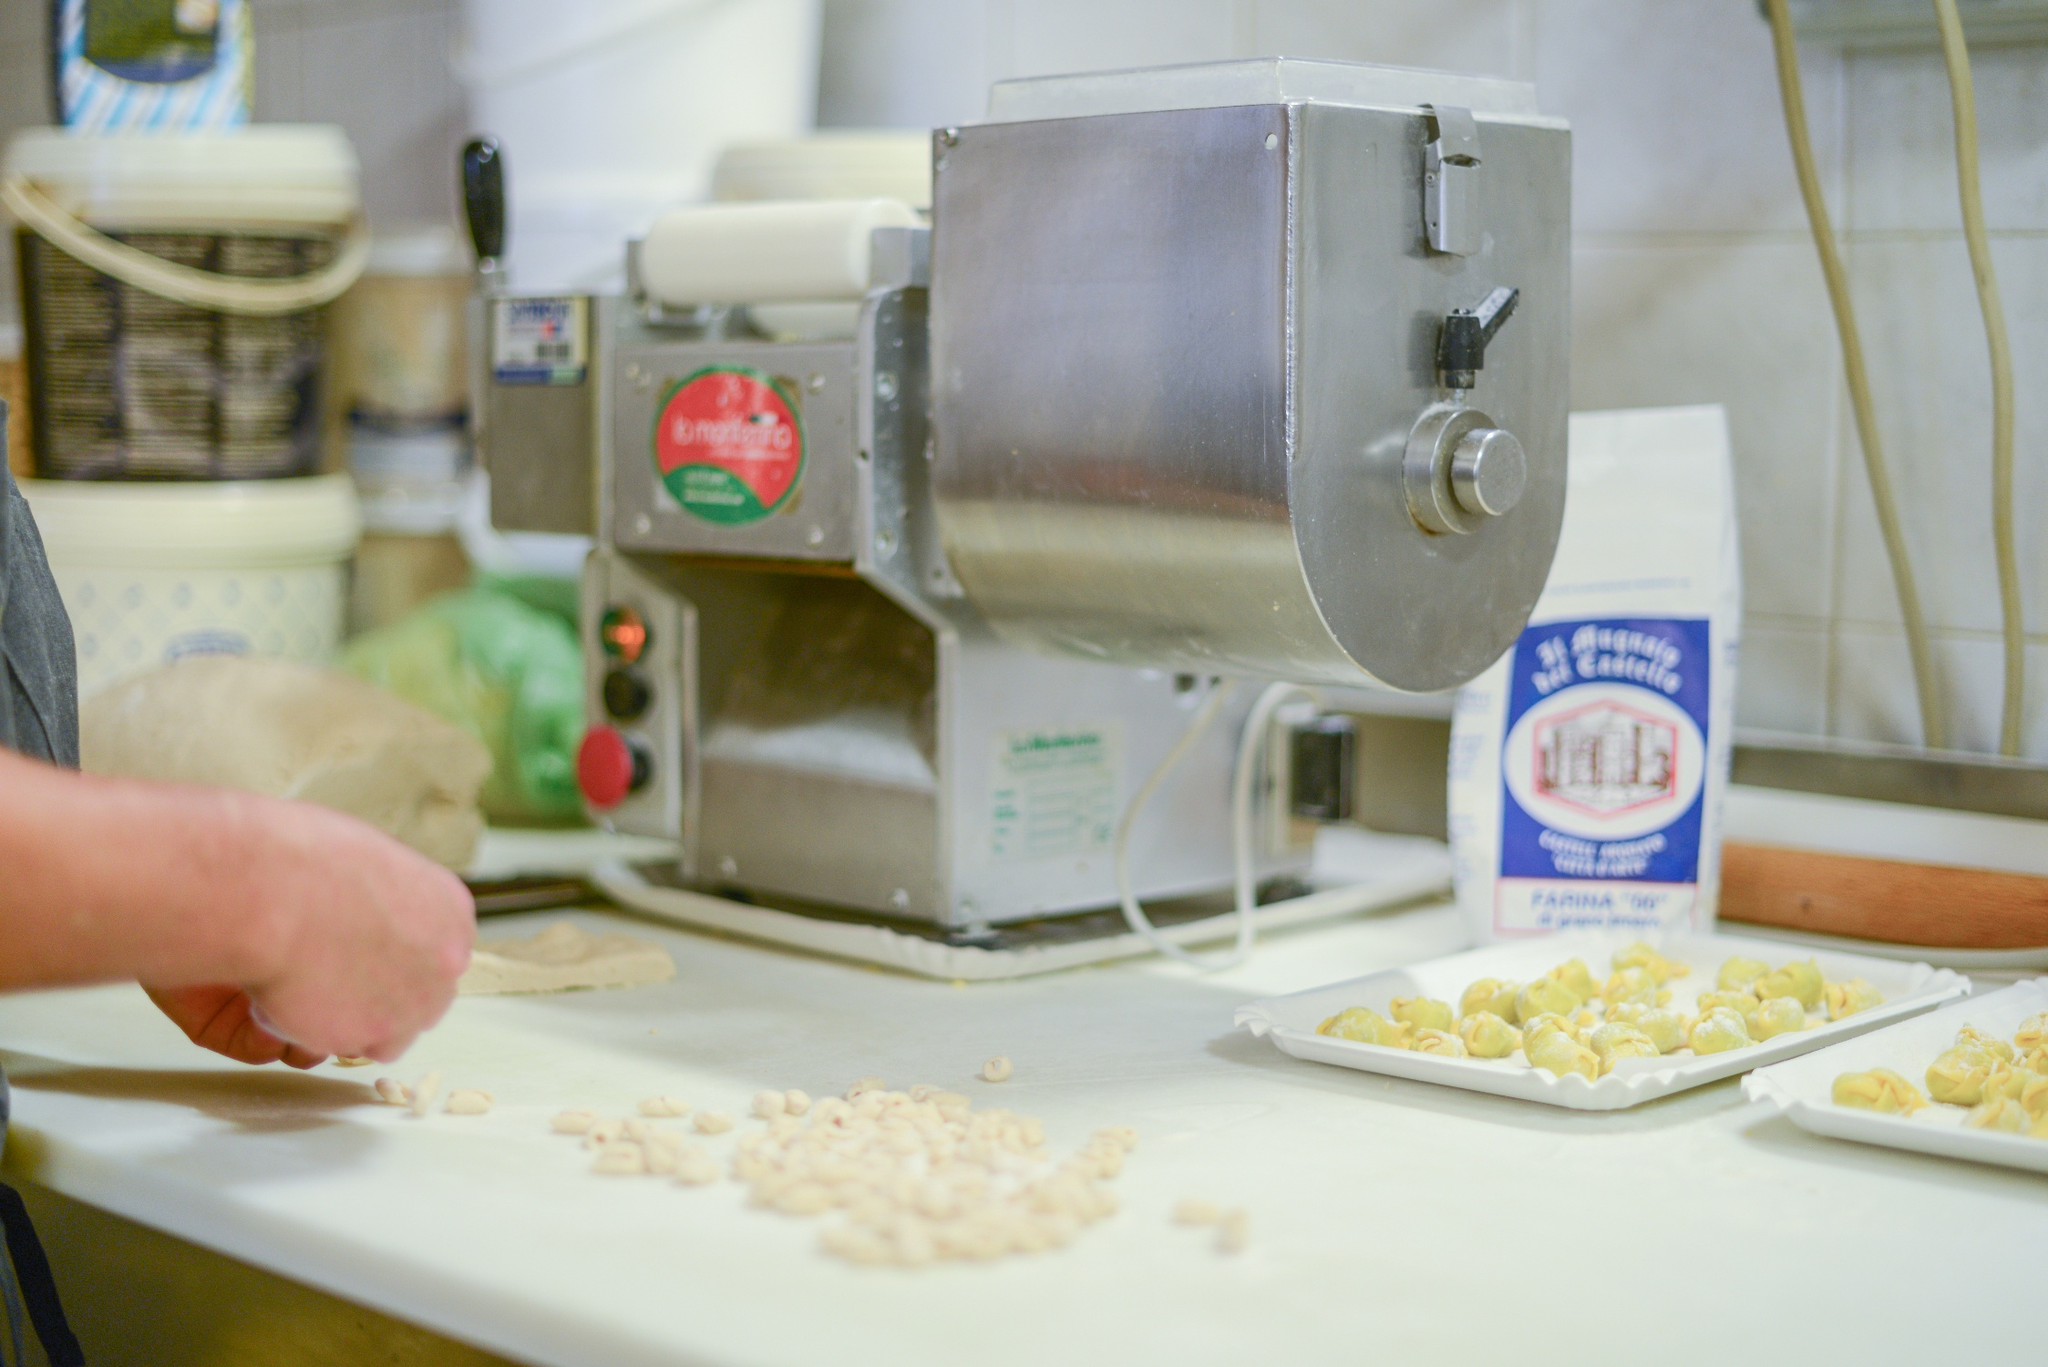Can you elaborate on the elements of the picture provided? The image captures a lively moment in a bustling kitchen where pasta-making is in full swing. At the center of this scene is a pasta machine, its metallic surface gleaming and adorned with a red label reading 'La monferrina'. Secured to a pristine white countertop, this machine is a testament to the culinary artistry unfolding before us.

In the foreground, a hand gently tends to a tray brimming with freshly made pasta, showcasing an array of shapes and sizes in a light yellow hue. Each piece hints at the dedication and meticulous effort invested in crafting them.

The countertop itself is a hub of activity, featuring essential tools like a white bowl with a blue rim and a white bag of 'La Molisana Farina Tipo 00' flour, indispensable in the pasta-making process.

The backdrop of white tiled walls adds a sense of cleanliness and order, while a nearby shelf, stocked with various kitchen items, infuses the scene with warmth and functionality.

Captured from the side, the perspective draws viewers into this intimate culinary moment, painting a vivid picture of the joy and satisfaction inherent in homemade pasta creation. This image is a heartfelt tribute to the skill and love that goes into making pasta from scratch. 